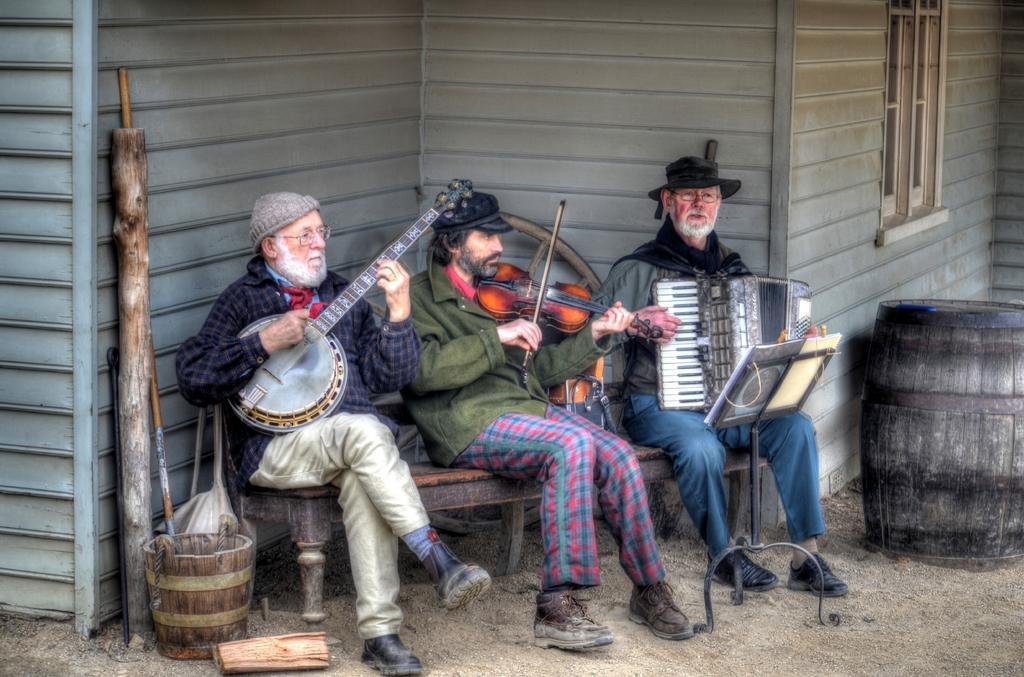Describe this image in one or two sentences. In this image we can see three persons sitting on a chair. One person is wearing a cap, spectacles are holding a guitar in his hand. One person is holding a violin in his hand. One person is holding a musical instrument in his hand. To the right side of the image we can see a book placed in a stand and a barrel. To the left side of the image we can see wood log and a bucket on the ground. In the background, we can see a building. 